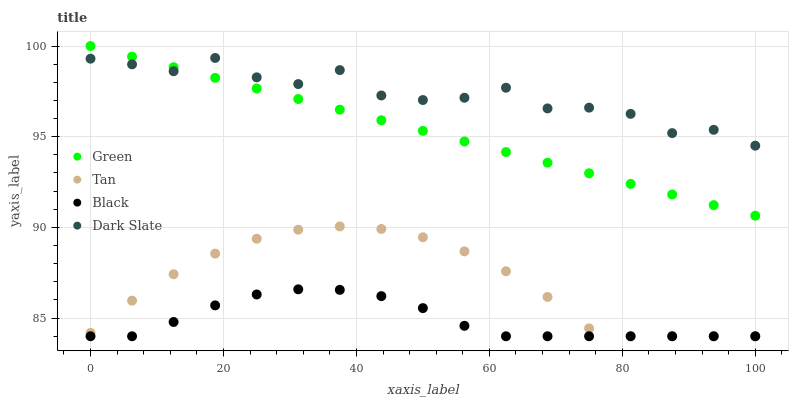Does Black have the minimum area under the curve?
Answer yes or no. Yes. Does Dark Slate have the maximum area under the curve?
Answer yes or no. Yes. Does Tan have the minimum area under the curve?
Answer yes or no. No. Does Tan have the maximum area under the curve?
Answer yes or no. No. Is Green the smoothest?
Answer yes or no. Yes. Is Dark Slate the roughest?
Answer yes or no. Yes. Is Tan the smoothest?
Answer yes or no. No. Is Tan the roughest?
Answer yes or no. No. Does Black have the lowest value?
Answer yes or no. Yes. Does Green have the lowest value?
Answer yes or no. No. Does Green have the highest value?
Answer yes or no. Yes. Does Tan have the highest value?
Answer yes or no. No. Is Black less than Dark Slate?
Answer yes or no. Yes. Is Green greater than Black?
Answer yes or no. Yes. Does Tan intersect Black?
Answer yes or no. Yes. Is Tan less than Black?
Answer yes or no. No. Is Tan greater than Black?
Answer yes or no. No. Does Black intersect Dark Slate?
Answer yes or no. No. 